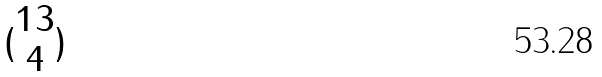<formula> <loc_0><loc_0><loc_500><loc_500>( \begin{matrix} 1 3 \\ 4 \end{matrix} )</formula> 